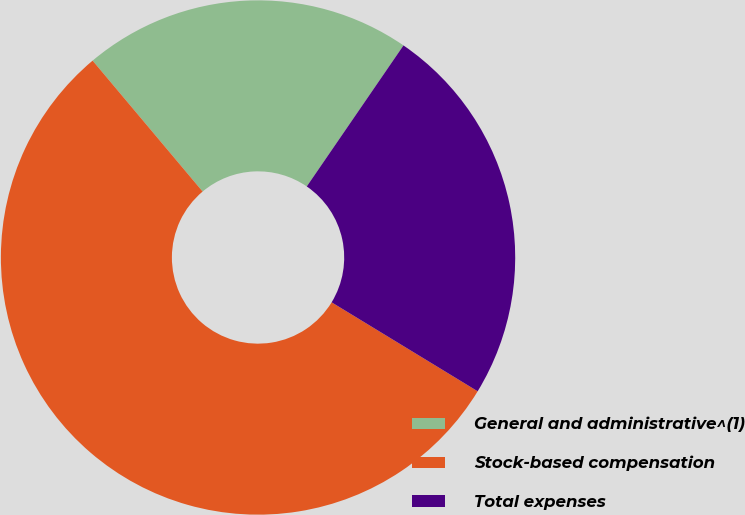<chart> <loc_0><loc_0><loc_500><loc_500><pie_chart><fcel>General and administrative^(1)<fcel>Stock-based compensation<fcel>Total expenses<nl><fcel>20.69%<fcel>55.17%<fcel>24.14%<nl></chart> 